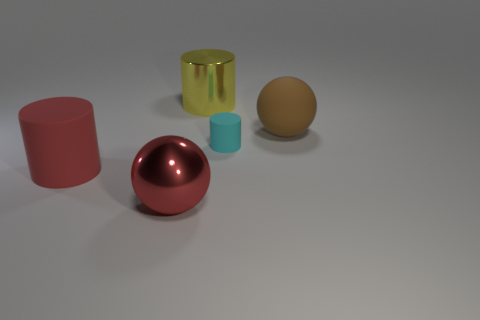Add 3 big red things. How many objects exist? 8 Subtract all big yellow metallic cylinders. How many cylinders are left? 2 Subtract all cylinders. How many objects are left? 2 Subtract all green matte cubes. Subtract all red objects. How many objects are left? 3 Add 1 large yellow cylinders. How many large yellow cylinders are left? 2 Add 5 red matte cylinders. How many red matte cylinders exist? 6 Subtract 0 green cubes. How many objects are left? 5 